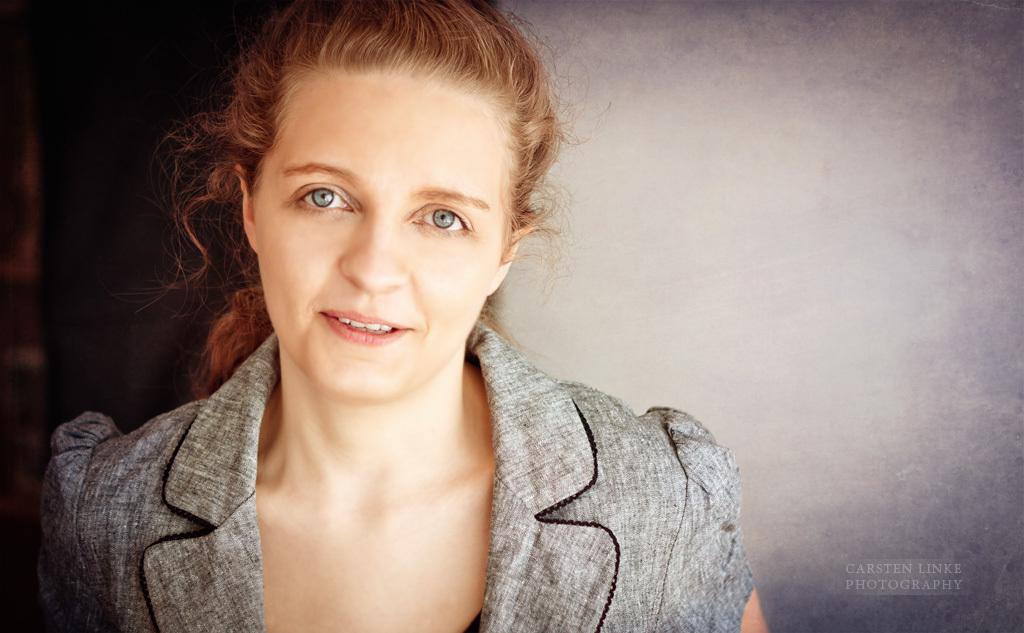Who is present in the image? There is a woman in the image. What can be seen in the background of the image? There is a wall in the background of the image. Is there any text visible in the image? Yes, there is some text visible in the image. What type of wren can be seen perched on the woman's shoulder in the image? There is no wren present in the image; only the woman, wall, and text are visible. 